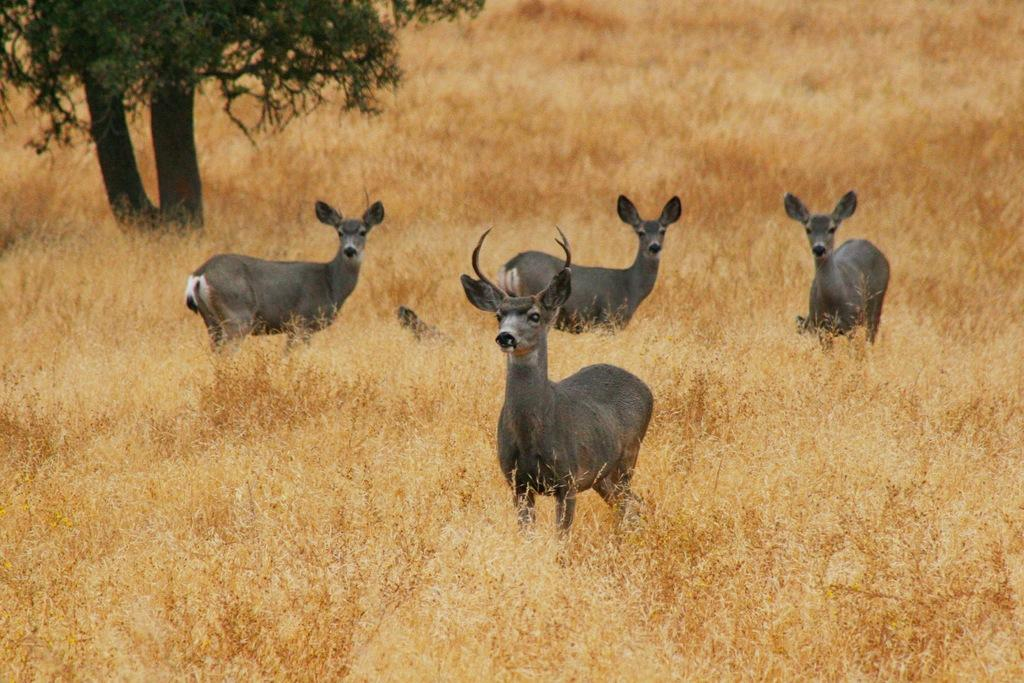What animals are present in the image? There are deer standing on the ground in the image. What type of vegetation can be seen in the image? There are plants and grass in the image. Where is the tree located in the image? There is a tree in the top left corner of the image. What type of meat is being prepared on the grill in the image? There is no grill or meat present in the image; it features deer standing on the ground, plants, grass, and a tree. What insect is crawling on the deer in the image? There are no insects visible on the deer in the image. 